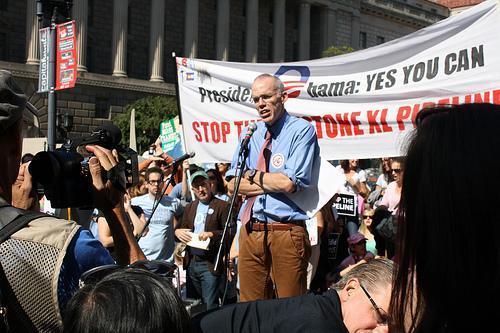How many white Obama banners are there?
Give a very brief answer. 1. How many tigers are running?
Give a very brief answer. 0. 